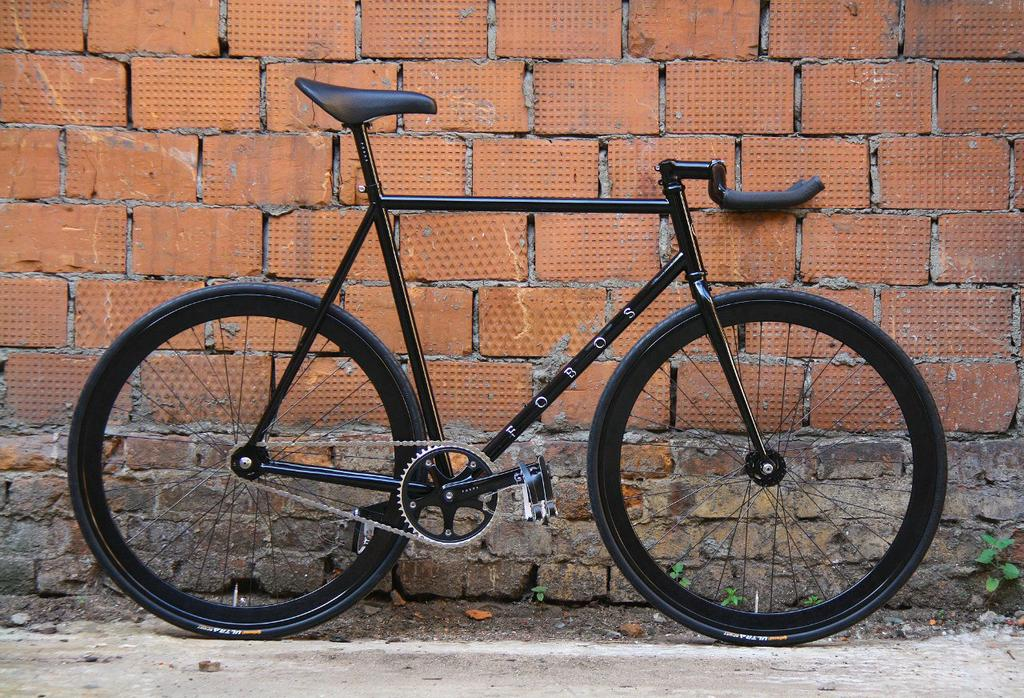What is the main object in the image? There is a bicycle in the image. What color is the bicycle? The bicycle is black. What type of background can be seen in the image? There is a brown color brick wall in the image. Are there any natural elements visible in the image? Yes, there are plants visible in the image. How many eggs are on the bicycle in the image? There are no eggs present on the bicycle in the image. What type of toy is visible in the image? There is no toy visible in the image; it features a black bicycle and a brown color brick wall with plants. 